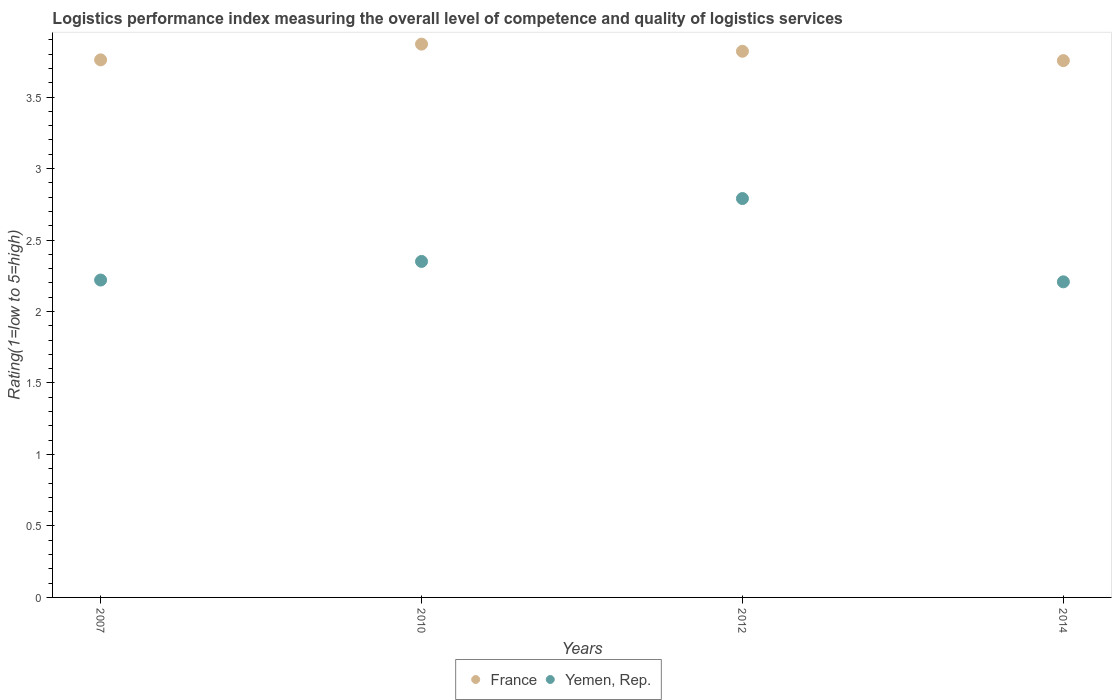What is the Logistic performance index in France in 2007?
Provide a succinct answer. 3.76. Across all years, what is the maximum Logistic performance index in Yemen, Rep.?
Your answer should be compact. 2.79. Across all years, what is the minimum Logistic performance index in France?
Your answer should be very brief. 3.75. In which year was the Logistic performance index in Yemen, Rep. maximum?
Provide a short and direct response. 2012. In which year was the Logistic performance index in France minimum?
Your answer should be very brief. 2014. What is the total Logistic performance index in France in the graph?
Your answer should be compact. 15.2. What is the difference between the Logistic performance index in Yemen, Rep. in 2007 and that in 2012?
Keep it short and to the point. -0.57. What is the difference between the Logistic performance index in France in 2010 and the Logistic performance index in Yemen, Rep. in 2007?
Provide a short and direct response. 1.65. What is the average Logistic performance index in Yemen, Rep. per year?
Provide a succinct answer. 2.39. In the year 2007, what is the difference between the Logistic performance index in Yemen, Rep. and Logistic performance index in France?
Provide a short and direct response. -1.54. What is the ratio of the Logistic performance index in Yemen, Rep. in 2007 to that in 2012?
Keep it short and to the point. 0.8. Is the difference between the Logistic performance index in Yemen, Rep. in 2007 and 2012 greater than the difference between the Logistic performance index in France in 2007 and 2012?
Your answer should be very brief. No. What is the difference between the highest and the second highest Logistic performance index in Yemen, Rep.?
Your answer should be very brief. 0.44. What is the difference between the highest and the lowest Logistic performance index in France?
Your answer should be very brief. 0.12. In how many years, is the Logistic performance index in Yemen, Rep. greater than the average Logistic performance index in Yemen, Rep. taken over all years?
Your answer should be compact. 1. Is the sum of the Logistic performance index in France in 2012 and 2014 greater than the maximum Logistic performance index in Yemen, Rep. across all years?
Provide a short and direct response. Yes. Does the Logistic performance index in Yemen, Rep. monotonically increase over the years?
Provide a succinct answer. No. Is the Logistic performance index in France strictly greater than the Logistic performance index in Yemen, Rep. over the years?
Make the answer very short. Yes. How many years are there in the graph?
Offer a terse response. 4. What is the difference between two consecutive major ticks on the Y-axis?
Provide a succinct answer. 0.5. Does the graph contain grids?
Your response must be concise. No. What is the title of the graph?
Your answer should be compact. Logistics performance index measuring the overall level of competence and quality of logistics services. What is the label or title of the Y-axis?
Offer a terse response. Rating(1=low to 5=high). What is the Rating(1=low to 5=high) of France in 2007?
Offer a terse response. 3.76. What is the Rating(1=low to 5=high) in Yemen, Rep. in 2007?
Your answer should be compact. 2.22. What is the Rating(1=low to 5=high) in France in 2010?
Provide a succinct answer. 3.87. What is the Rating(1=low to 5=high) in Yemen, Rep. in 2010?
Make the answer very short. 2.35. What is the Rating(1=low to 5=high) of France in 2012?
Your answer should be compact. 3.82. What is the Rating(1=low to 5=high) in Yemen, Rep. in 2012?
Keep it short and to the point. 2.79. What is the Rating(1=low to 5=high) of France in 2014?
Give a very brief answer. 3.75. What is the Rating(1=low to 5=high) in Yemen, Rep. in 2014?
Offer a very short reply. 2.21. Across all years, what is the maximum Rating(1=low to 5=high) in France?
Make the answer very short. 3.87. Across all years, what is the maximum Rating(1=low to 5=high) of Yemen, Rep.?
Your answer should be very brief. 2.79. Across all years, what is the minimum Rating(1=low to 5=high) in France?
Offer a terse response. 3.75. Across all years, what is the minimum Rating(1=low to 5=high) of Yemen, Rep.?
Your response must be concise. 2.21. What is the total Rating(1=low to 5=high) in France in the graph?
Keep it short and to the point. 15.2. What is the total Rating(1=low to 5=high) of Yemen, Rep. in the graph?
Give a very brief answer. 9.57. What is the difference between the Rating(1=low to 5=high) in France in 2007 and that in 2010?
Your answer should be compact. -0.11. What is the difference between the Rating(1=low to 5=high) in Yemen, Rep. in 2007 and that in 2010?
Keep it short and to the point. -0.13. What is the difference between the Rating(1=low to 5=high) of France in 2007 and that in 2012?
Your answer should be compact. -0.06. What is the difference between the Rating(1=low to 5=high) in Yemen, Rep. in 2007 and that in 2012?
Offer a very short reply. -0.57. What is the difference between the Rating(1=low to 5=high) in France in 2007 and that in 2014?
Provide a succinct answer. 0.01. What is the difference between the Rating(1=low to 5=high) of Yemen, Rep. in 2007 and that in 2014?
Ensure brevity in your answer.  0.01. What is the difference between the Rating(1=low to 5=high) in Yemen, Rep. in 2010 and that in 2012?
Offer a very short reply. -0.44. What is the difference between the Rating(1=low to 5=high) of France in 2010 and that in 2014?
Make the answer very short. 0.12. What is the difference between the Rating(1=low to 5=high) in Yemen, Rep. in 2010 and that in 2014?
Provide a short and direct response. 0.14. What is the difference between the Rating(1=low to 5=high) of France in 2012 and that in 2014?
Provide a short and direct response. 0.07. What is the difference between the Rating(1=low to 5=high) of Yemen, Rep. in 2012 and that in 2014?
Provide a succinct answer. 0.58. What is the difference between the Rating(1=low to 5=high) of France in 2007 and the Rating(1=low to 5=high) of Yemen, Rep. in 2010?
Your response must be concise. 1.41. What is the difference between the Rating(1=low to 5=high) of France in 2007 and the Rating(1=low to 5=high) of Yemen, Rep. in 2014?
Ensure brevity in your answer.  1.55. What is the difference between the Rating(1=low to 5=high) of France in 2010 and the Rating(1=low to 5=high) of Yemen, Rep. in 2014?
Your answer should be compact. 1.66. What is the difference between the Rating(1=low to 5=high) in France in 2012 and the Rating(1=low to 5=high) in Yemen, Rep. in 2014?
Keep it short and to the point. 1.61. What is the average Rating(1=low to 5=high) of France per year?
Provide a succinct answer. 3.8. What is the average Rating(1=low to 5=high) of Yemen, Rep. per year?
Provide a short and direct response. 2.39. In the year 2007, what is the difference between the Rating(1=low to 5=high) in France and Rating(1=low to 5=high) in Yemen, Rep.?
Give a very brief answer. 1.54. In the year 2010, what is the difference between the Rating(1=low to 5=high) in France and Rating(1=low to 5=high) in Yemen, Rep.?
Offer a terse response. 1.52. In the year 2014, what is the difference between the Rating(1=low to 5=high) in France and Rating(1=low to 5=high) in Yemen, Rep.?
Your answer should be very brief. 1.55. What is the ratio of the Rating(1=low to 5=high) of France in 2007 to that in 2010?
Ensure brevity in your answer.  0.97. What is the ratio of the Rating(1=low to 5=high) in Yemen, Rep. in 2007 to that in 2010?
Provide a succinct answer. 0.94. What is the ratio of the Rating(1=low to 5=high) of France in 2007 to that in 2012?
Provide a short and direct response. 0.98. What is the ratio of the Rating(1=low to 5=high) of Yemen, Rep. in 2007 to that in 2012?
Offer a terse response. 0.8. What is the ratio of the Rating(1=low to 5=high) in France in 2010 to that in 2012?
Your response must be concise. 1.01. What is the ratio of the Rating(1=low to 5=high) of Yemen, Rep. in 2010 to that in 2012?
Your answer should be very brief. 0.84. What is the ratio of the Rating(1=low to 5=high) in France in 2010 to that in 2014?
Provide a succinct answer. 1.03. What is the ratio of the Rating(1=low to 5=high) of Yemen, Rep. in 2010 to that in 2014?
Offer a very short reply. 1.06. What is the ratio of the Rating(1=low to 5=high) in France in 2012 to that in 2014?
Provide a succinct answer. 1.02. What is the ratio of the Rating(1=low to 5=high) in Yemen, Rep. in 2012 to that in 2014?
Provide a short and direct response. 1.26. What is the difference between the highest and the second highest Rating(1=low to 5=high) of France?
Offer a very short reply. 0.05. What is the difference between the highest and the second highest Rating(1=low to 5=high) of Yemen, Rep.?
Offer a terse response. 0.44. What is the difference between the highest and the lowest Rating(1=low to 5=high) of France?
Your response must be concise. 0.12. What is the difference between the highest and the lowest Rating(1=low to 5=high) in Yemen, Rep.?
Ensure brevity in your answer.  0.58. 